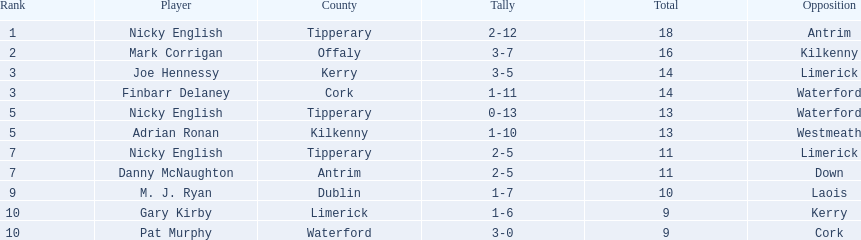Who was the highest-ranked player in a single match? Nicky English. 